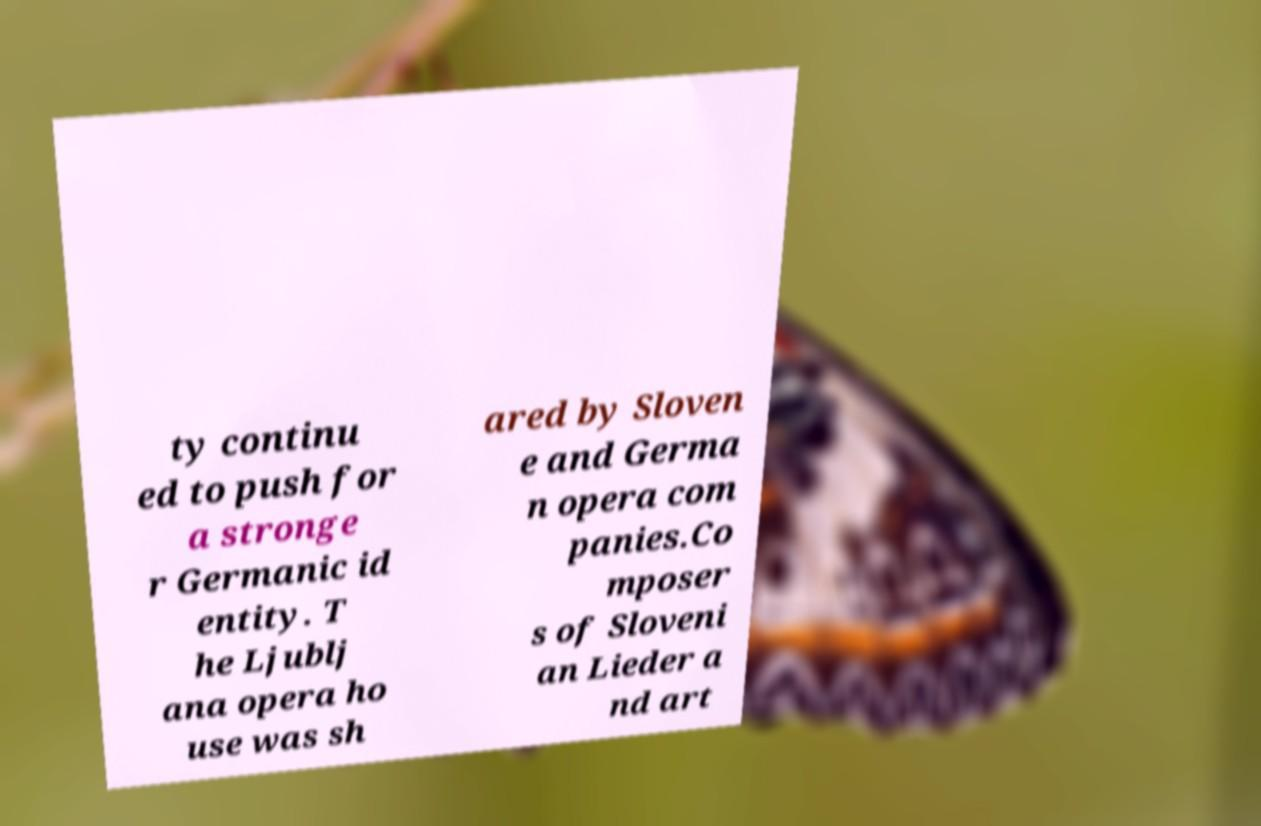I need the written content from this picture converted into text. Can you do that? ty continu ed to push for a stronge r Germanic id entity. T he Ljublj ana opera ho use was sh ared by Sloven e and Germa n opera com panies.Co mposer s of Sloveni an Lieder a nd art 